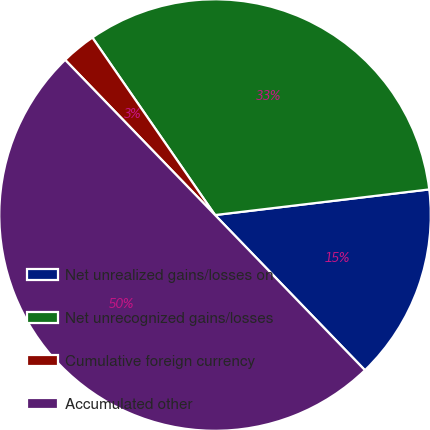Convert chart. <chart><loc_0><loc_0><loc_500><loc_500><pie_chart><fcel>Net unrealized gains/losses on<fcel>Net unrecognized gains/losses<fcel>Cumulative foreign currency<fcel>Accumulated other<nl><fcel>14.67%<fcel>32.73%<fcel>2.6%<fcel>50.0%<nl></chart> 